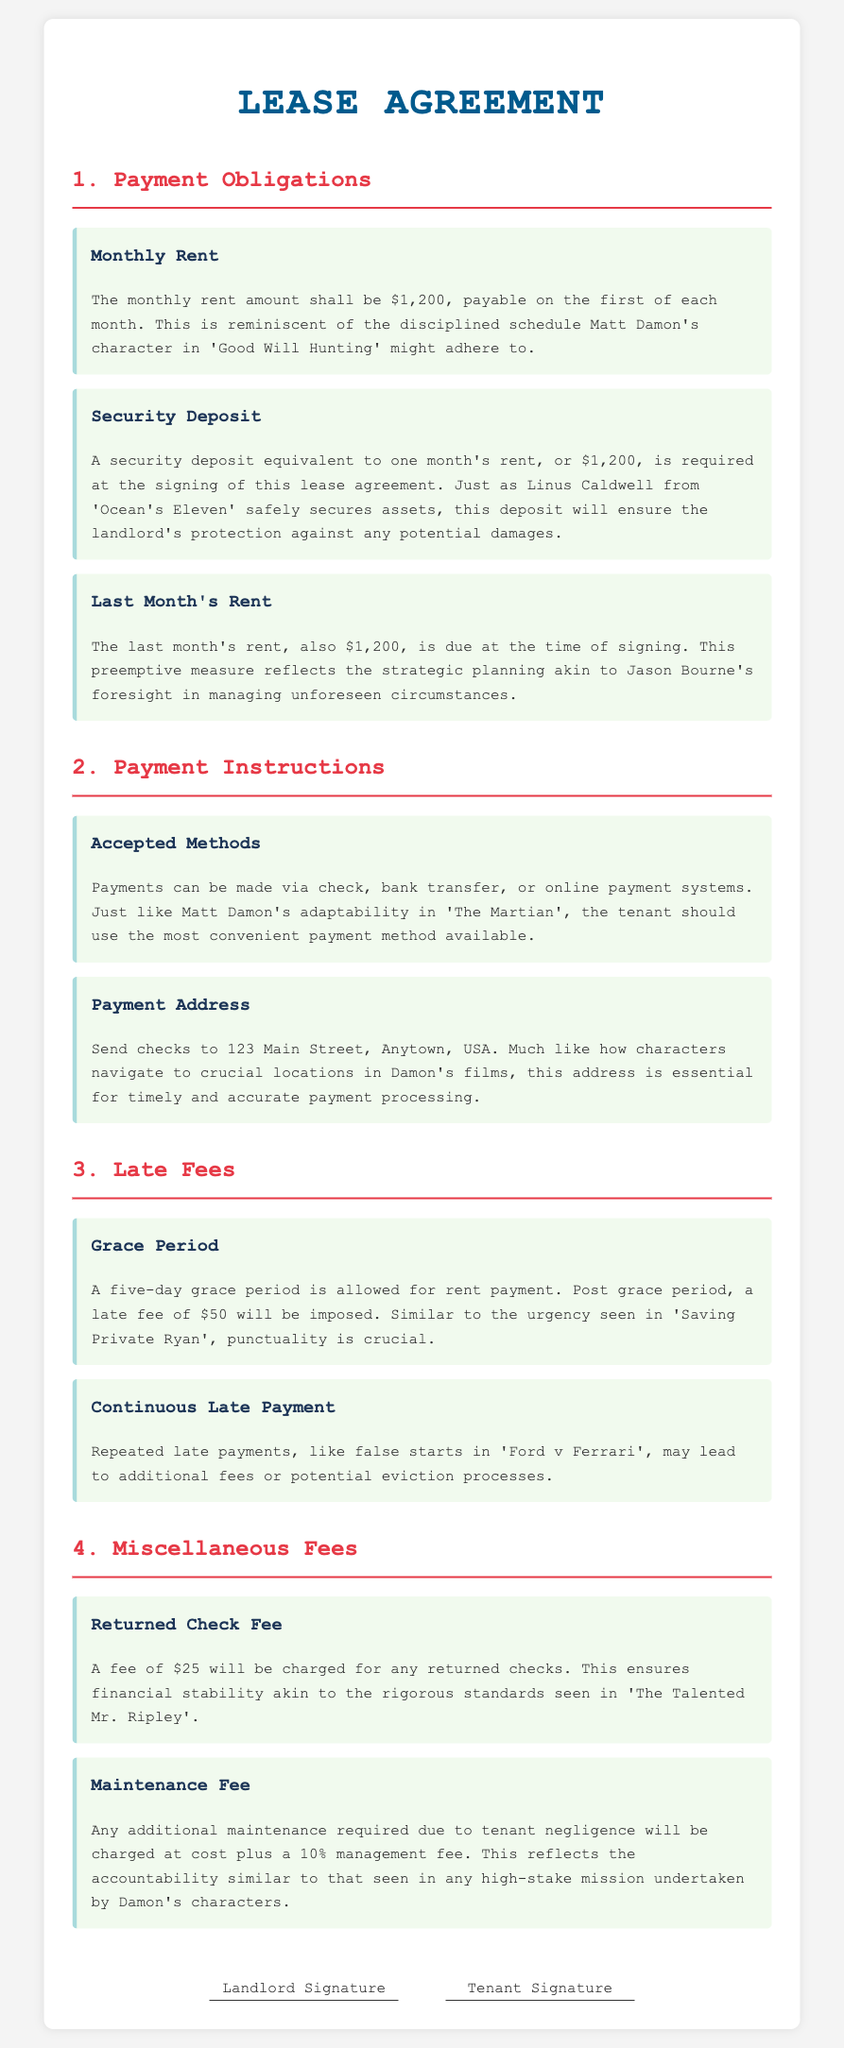what is the monthly rent? The monthly rent amount is specified in the document, which is $1,200.
Answer: $1,200 what is the amount of the security deposit? The security deposit is stated as equivalent to one month's rent, which is $1,200.
Answer: $1,200 how many days is the grace period for rent payment? The document outlines a grace period of five days for rent payment.
Answer: five days what is the late fee after the grace period? The late fee imposed after the grace period is specified as $50.
Answer: $50 how is the last month's rent related to Jason Bourne? The last month's rent reflects strategic planning akin to Jason Bourne's foresight.
Answer: strategic planning what occurs for repeated late payments? The document mentions that repeated late payments may lead to additional fees or potential eviction processes.
Answer: additional fees or potential eviction what is the returned check fee amount? The fee for any returned checks is stated as $25 in the document.
Answer: $25 what payment methods are accepted? The document lists check, bank transfer, or online payment systems as accepted payment methods.
Answer: check, bank transfer, online payment systems who signs the lease agreement? The lease agreement requires signatures from both the landlord and the tenant.
Answer: landlord and tenant 